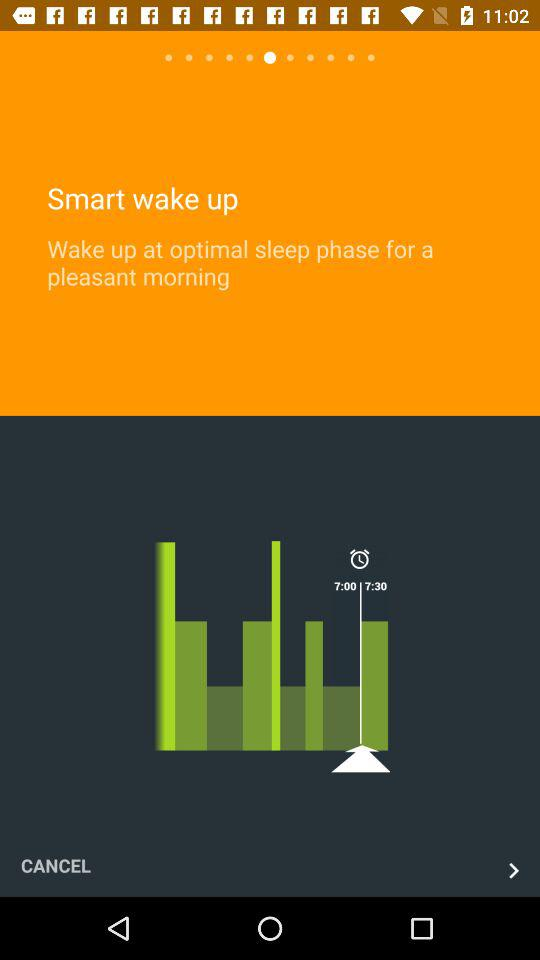How many minutes are between the 7:00 and 7:30 options?
Answer the question using a single word or phrase. 30 